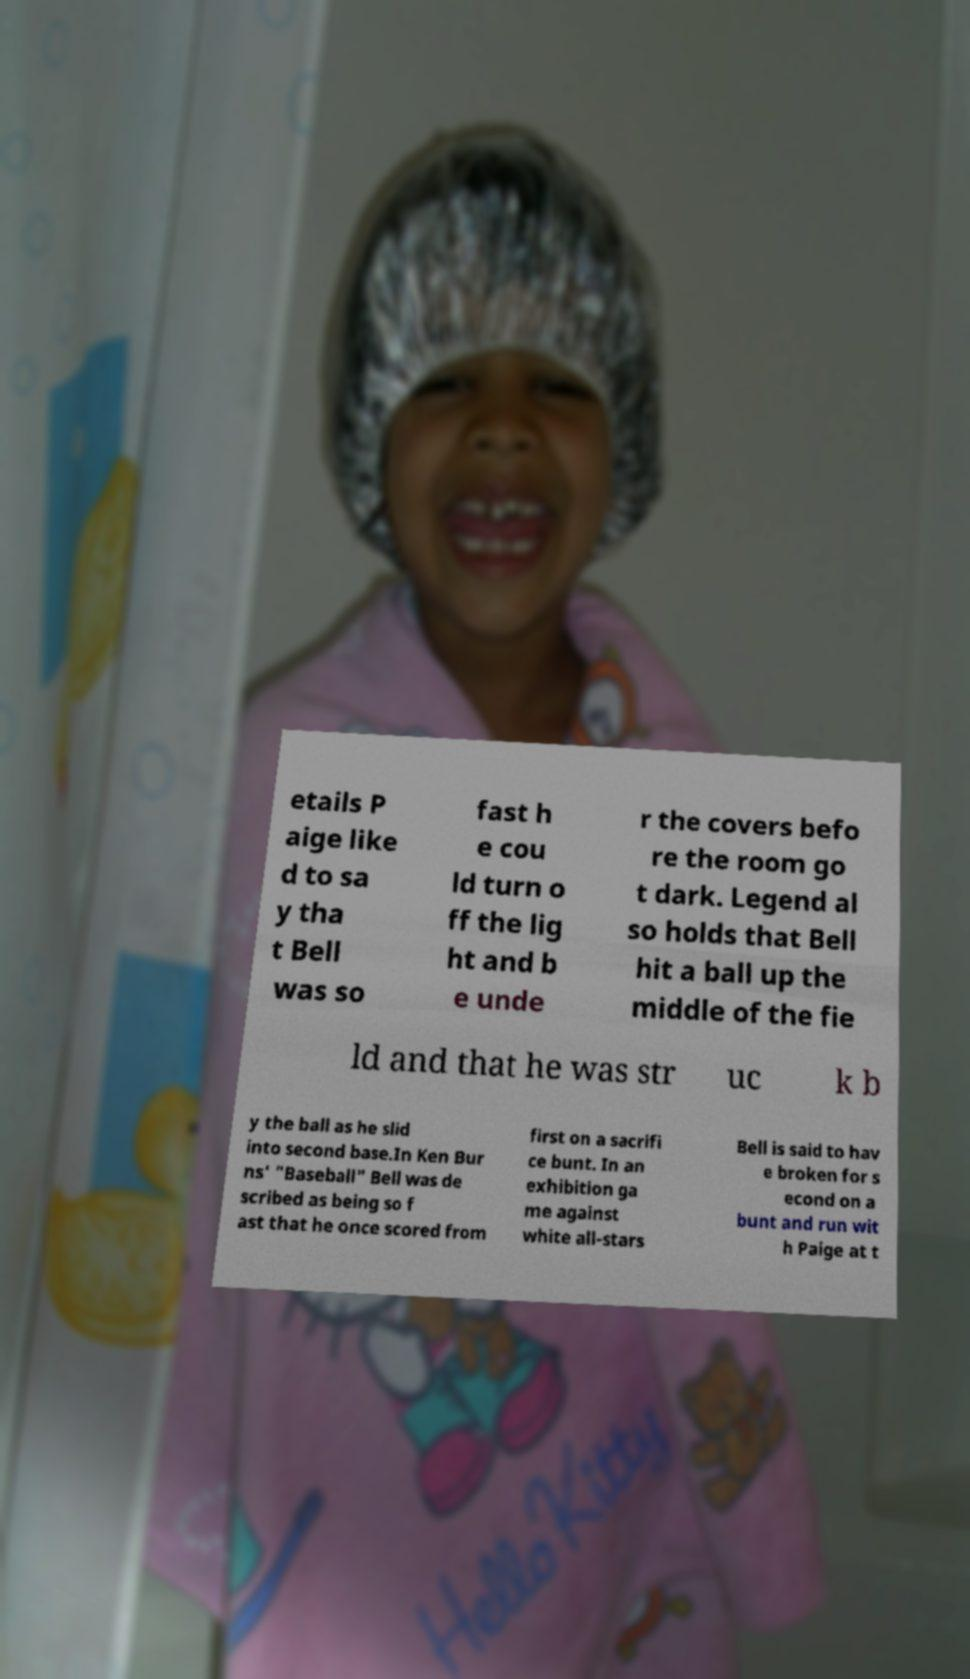There's text embedded in this image that I need extracted. Can you transcribe it verbatim? etails P aige like d to sa y tha t Bell was so fast h e cou ld turn o ff the lig ht and b e unde r the covers befo re the room go t dark. Legend al so holds that Bell hit a ball up the middle of the fie ld and that he was str uc k b y the ball as he slid into second base.In Ken Bur ns' "Baseball" Bell was de scribed as being so f ast that he once scored from first on a sacrifi ce bunt. In an exhibition ga me against white all-stars Bell is said to hav e broken for s econd on a bunt and run wit h Paige at t 